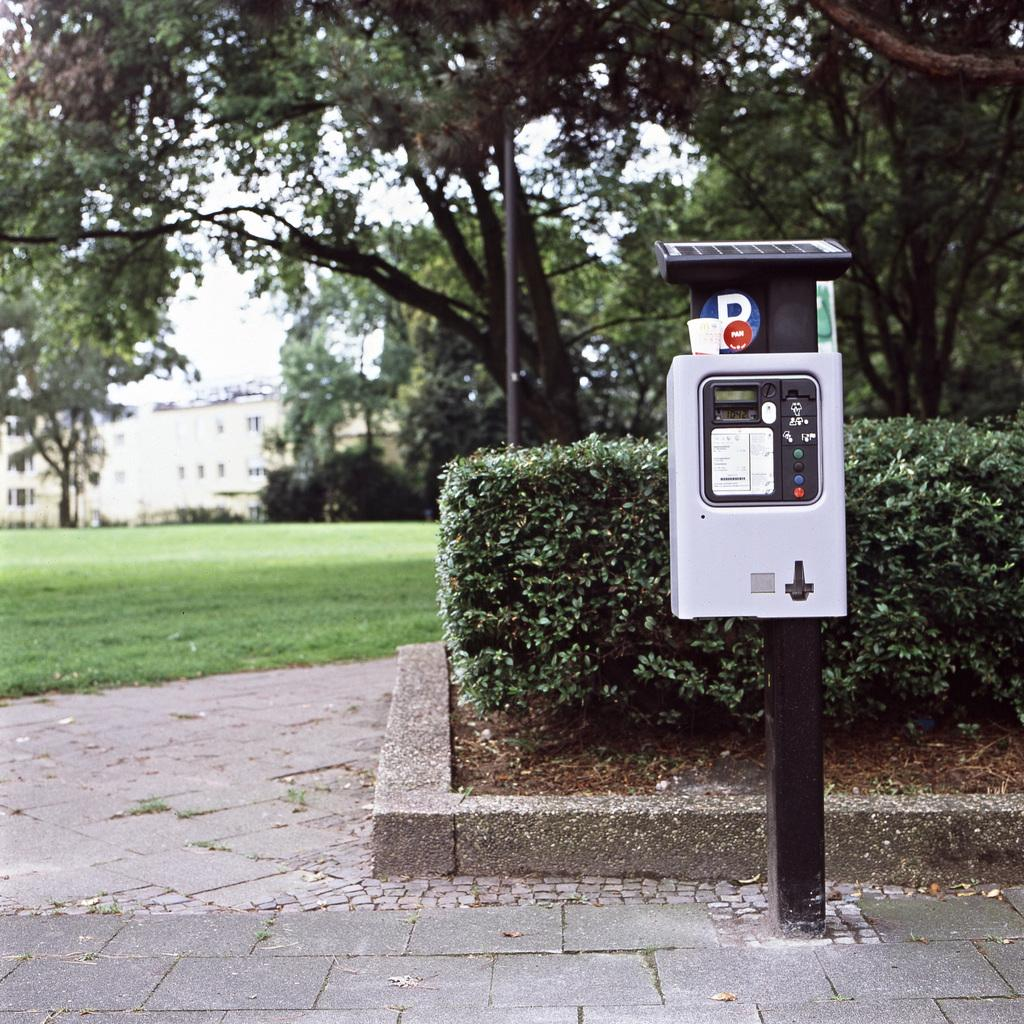What is attached to the pole in the image? There is an object attached to a pole in the image. What can be seen behind the object? There are plants behind the object. How is the ground depicted in the image? The ground is covered in greenery. What is visible in the background of the image? There are trees and buildings in the background of the image. What type of tin can be seen shaking in the image? There is no tin present in the image, nor is there any shaking motion depicted. 